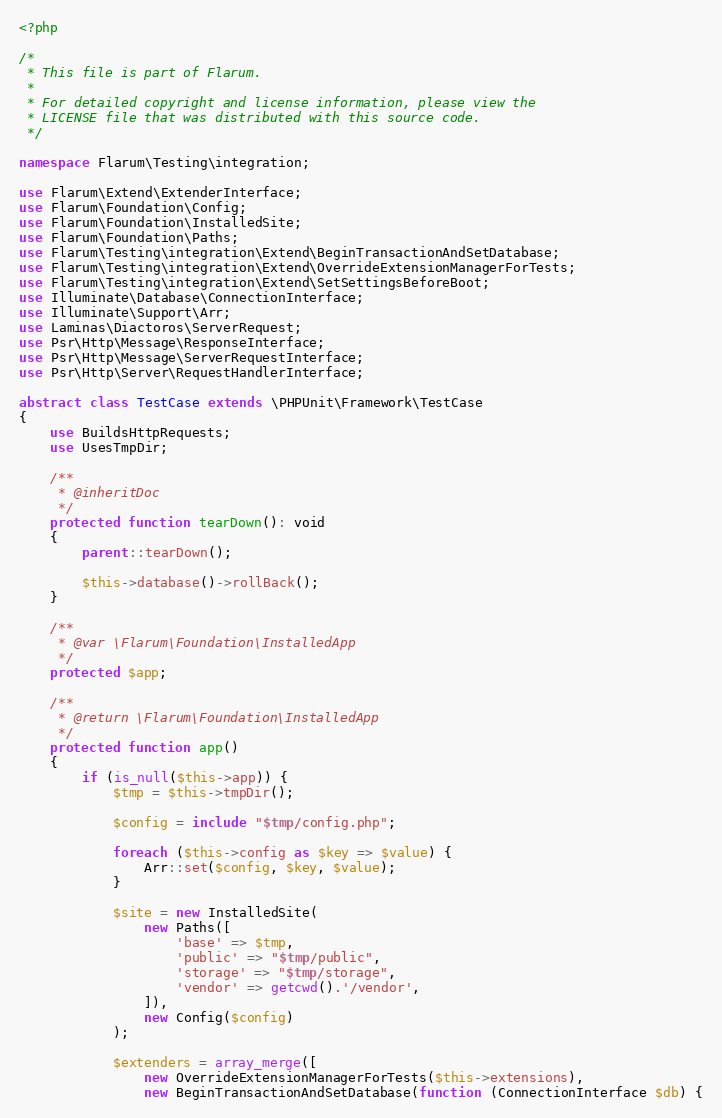<code> <loc_0><loc_0><loc_500><loc_500><_PHP_><?php

/*
 * This file is part of Flarum.
 *
 * For detailed copyright and license information, please view the
 * LICENSE file that was distributed with this source code.
 */

namespace Flarum\Testing\integration;

use Flarum\Extend\ExtenderInterface;
use Flarum\Foundation\Config;
use Flarum\Foundation\InstalledSite;
use Flarum\Foundation\Paths;
use Flarum\Testing\integration\Extend\BeginTransactionAndSetDatabase;
use Flarum\Testing\integration\Extend\OverrideExtensionManagerForTests;
use Flarum\Testing\integration\Extend\SetSettingsBeforeBoot;
use Illuminate\Database\ConnectionInterface;
use Illuminate\Support\Arr;
use Laminas\Diactoros\ServerRequest;
use Psr\Http\Message\ResponseInterface;
use Psr\Http\Message\ServerRequestInterface;
use Psr\Http\Server\RequestHandlerInterface;

abstract class TestCase extends \PHPUnit\Framework\TestCase
{
    use BuildsHttpRequests;
    use UsesTmpDir;

    /**
     * @inheritDoc
     */
    protected function tearDown(): void
    {
        parent::tearDown();

        $this->database()->rollBack();
    }

    /**
     * @var \Flarum\Foundation\InstalledApp
     */
    protected $app;

    /**
     * @return \Flarum\Foundation\InstalledApp
     */
    protected function app()
    {
        if (is_null($this->app)) {
            $tmp = $this->tmpDir();

            $config = include "$tmp/config.php";

            foreach ($this->config as $key => $value) {
                Arr::set($config, $key, $value);
            }

            $site = new InstalledSite(
                new Paths([
                    'base' => $tmp,
                    'public' => "$tmp/public",
                    'storage' => "$tmp/storage",
                    'vendor' => getcwd().'/vendor',
                ]),
                new Config($config)
            );

            $extenders = array_merge([
                new OverrideExtensionManagerForTests($this->extensions),
                new BeginTransactionAndSetDatabase(function (ConnectionInterface $db) {</code> 